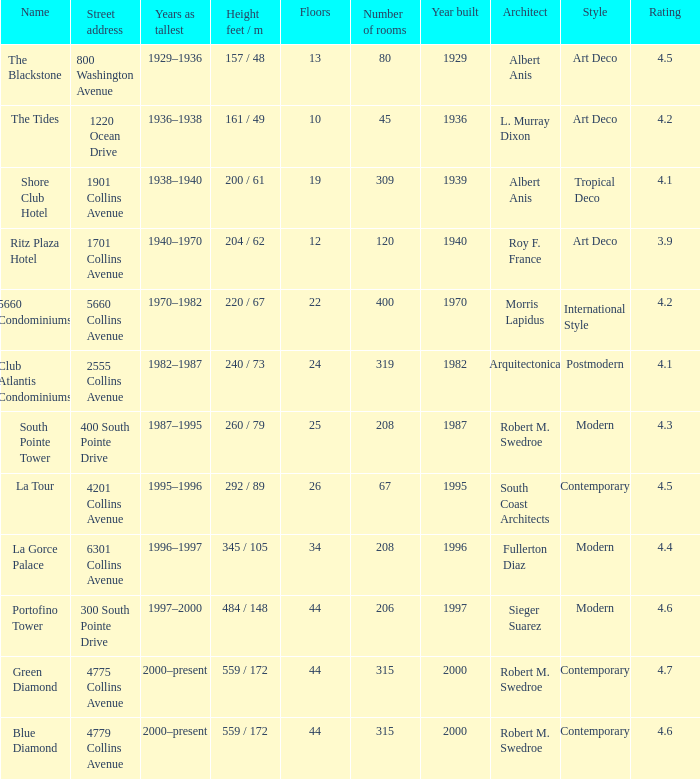What is the height of the Tides with less than 34 floors? 161 / 49. 